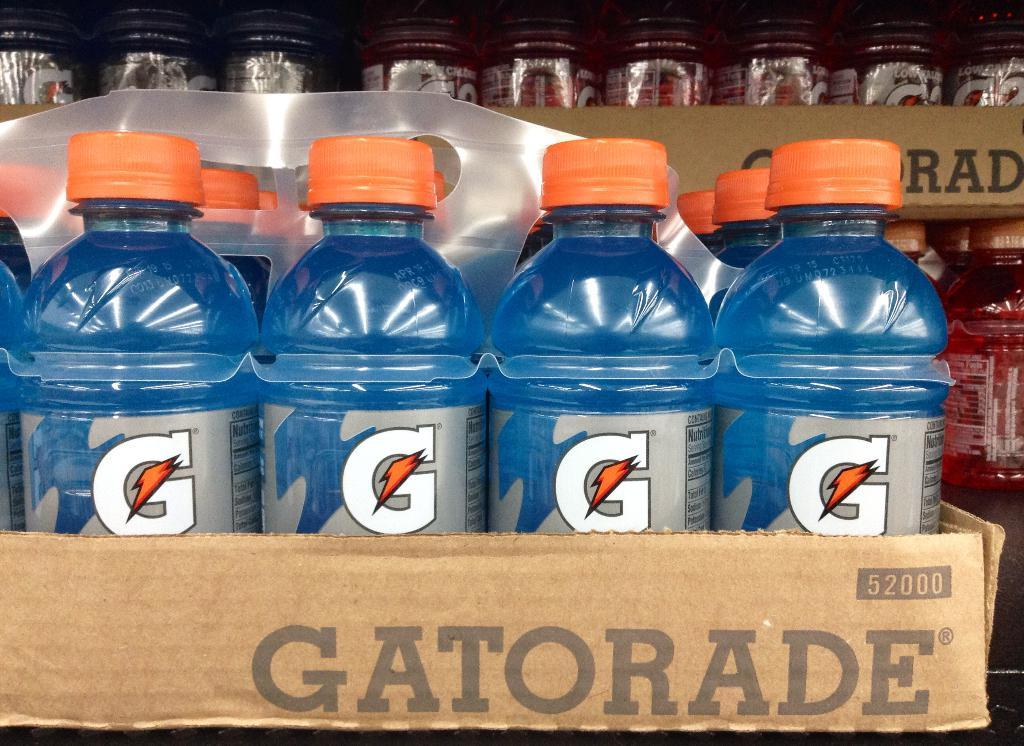<image>
Summarize the visual content of the image. A case of blue gatorade with more stacks behind it. 